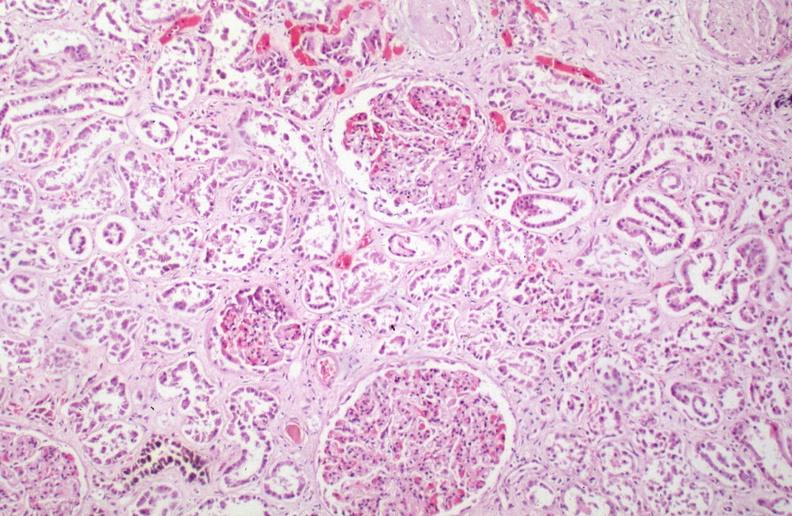what caused by numerous blood transfusions?
Answer the question using a single word or phrase. Hemosiderosis 